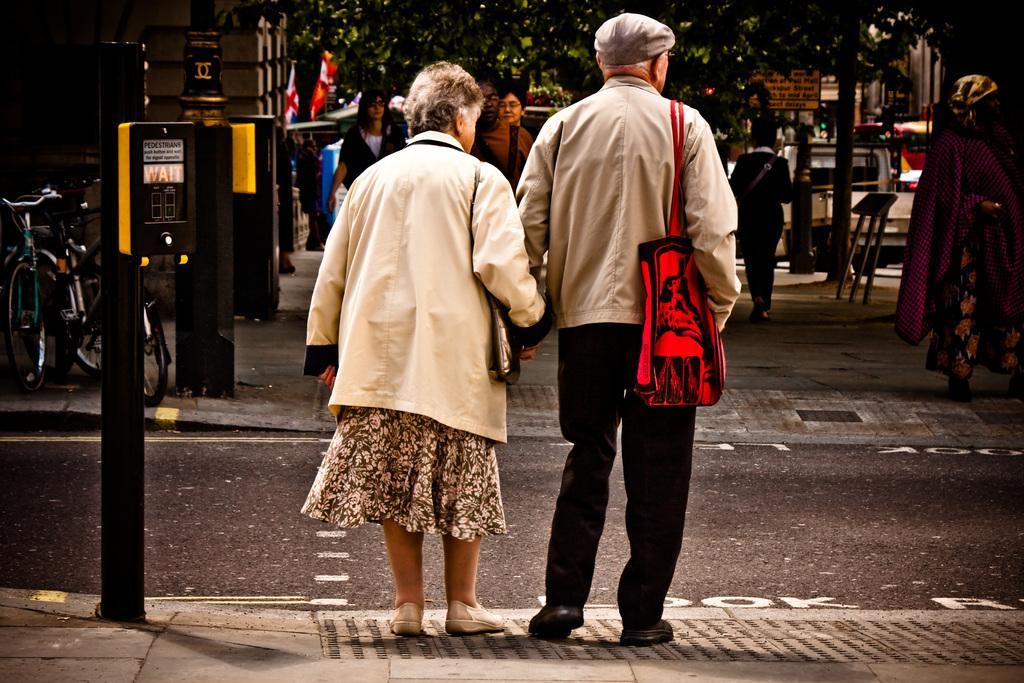Describe this image in one or two sentences. This is the picture of a road. In this image there are two persons standing on the footpath. At the back there are group of people walking and there are buildings and trees and there is a vehicle. On the left side of the image there are poles on the footpath and there are bicycles on the footpath and there are flags. At the bottom there is a road. 